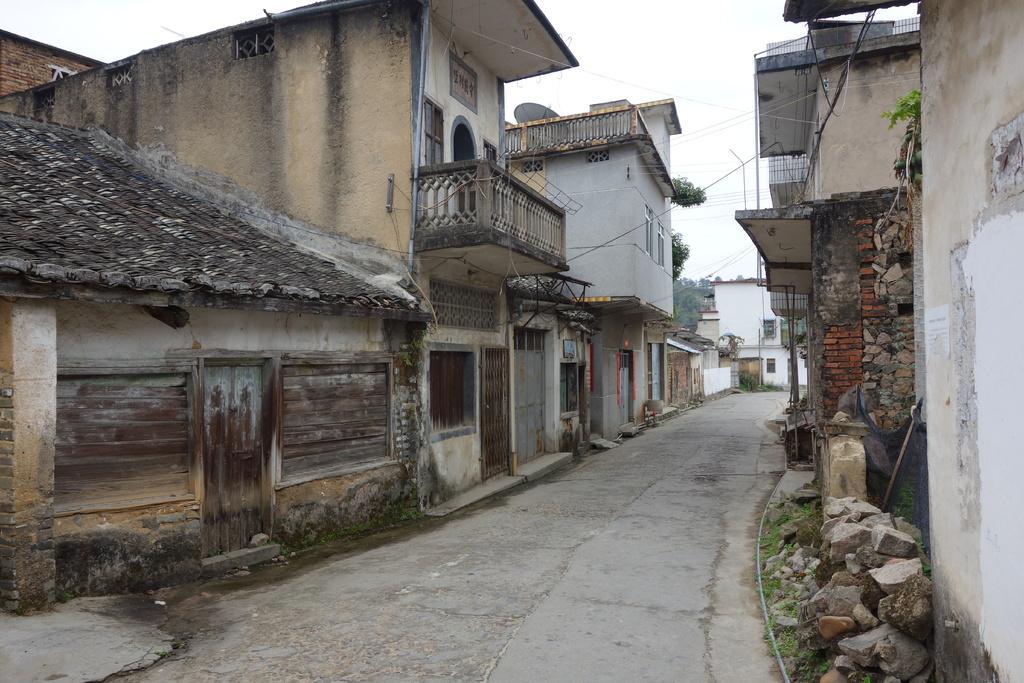How would you summarize this image in a sentence or two? In this picture we can see the path, stones, buildings with windows, doors and some objects and in the background we can see trees and the sky. 